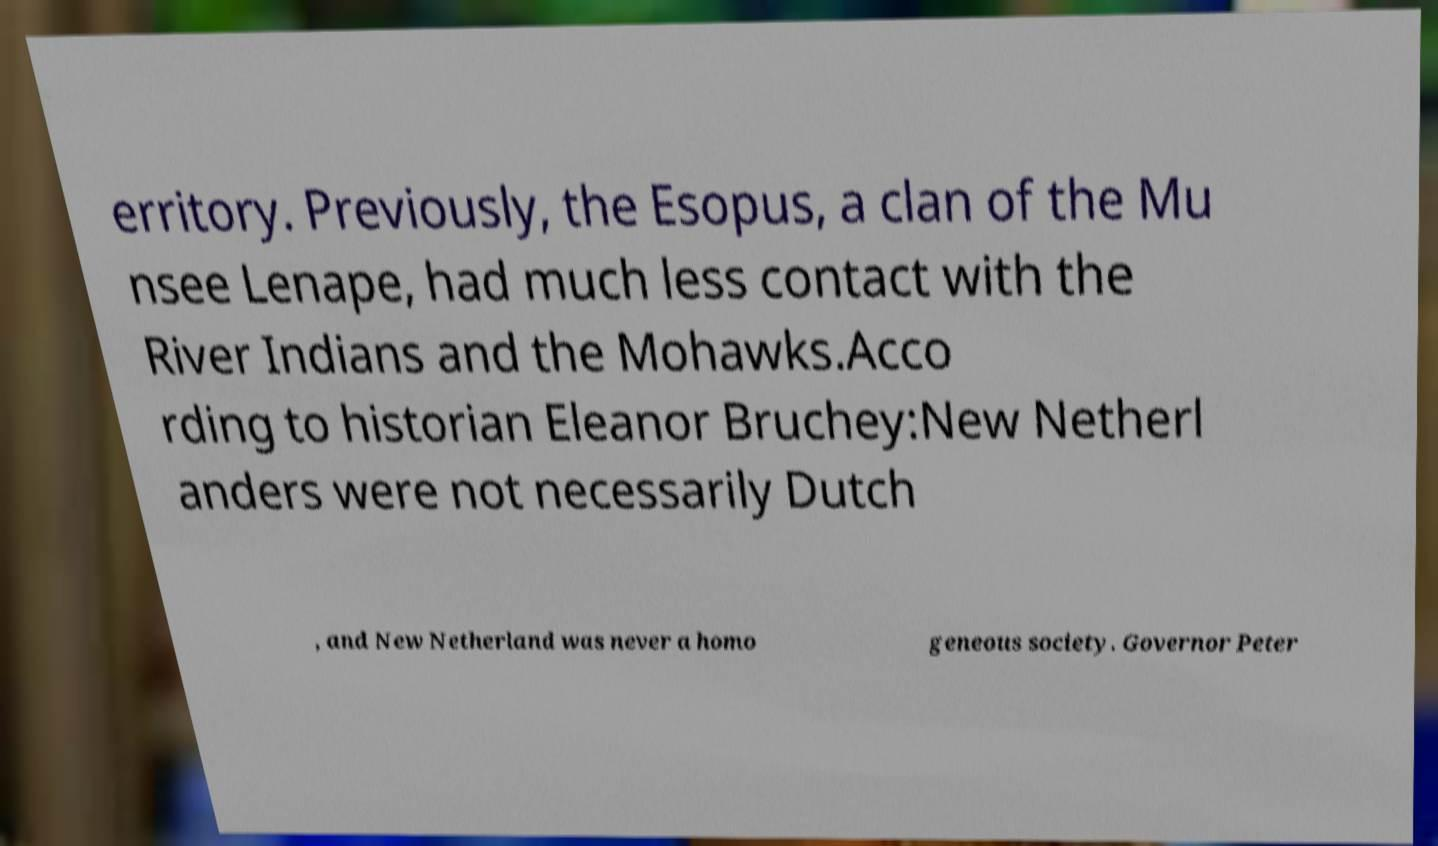Could you assist in decoding the text presented in this image and type it out clearly? erritory. Previously, the Esopus, a clan of the Mu nsee Lenape, had much less contact with the River Indians and the Mohawks.Acco rding to historian Eleanor Bruchey:New Netherl anders were not necessarily Dutch , and New Netherland was never a homo geneous society. Governor Peter 